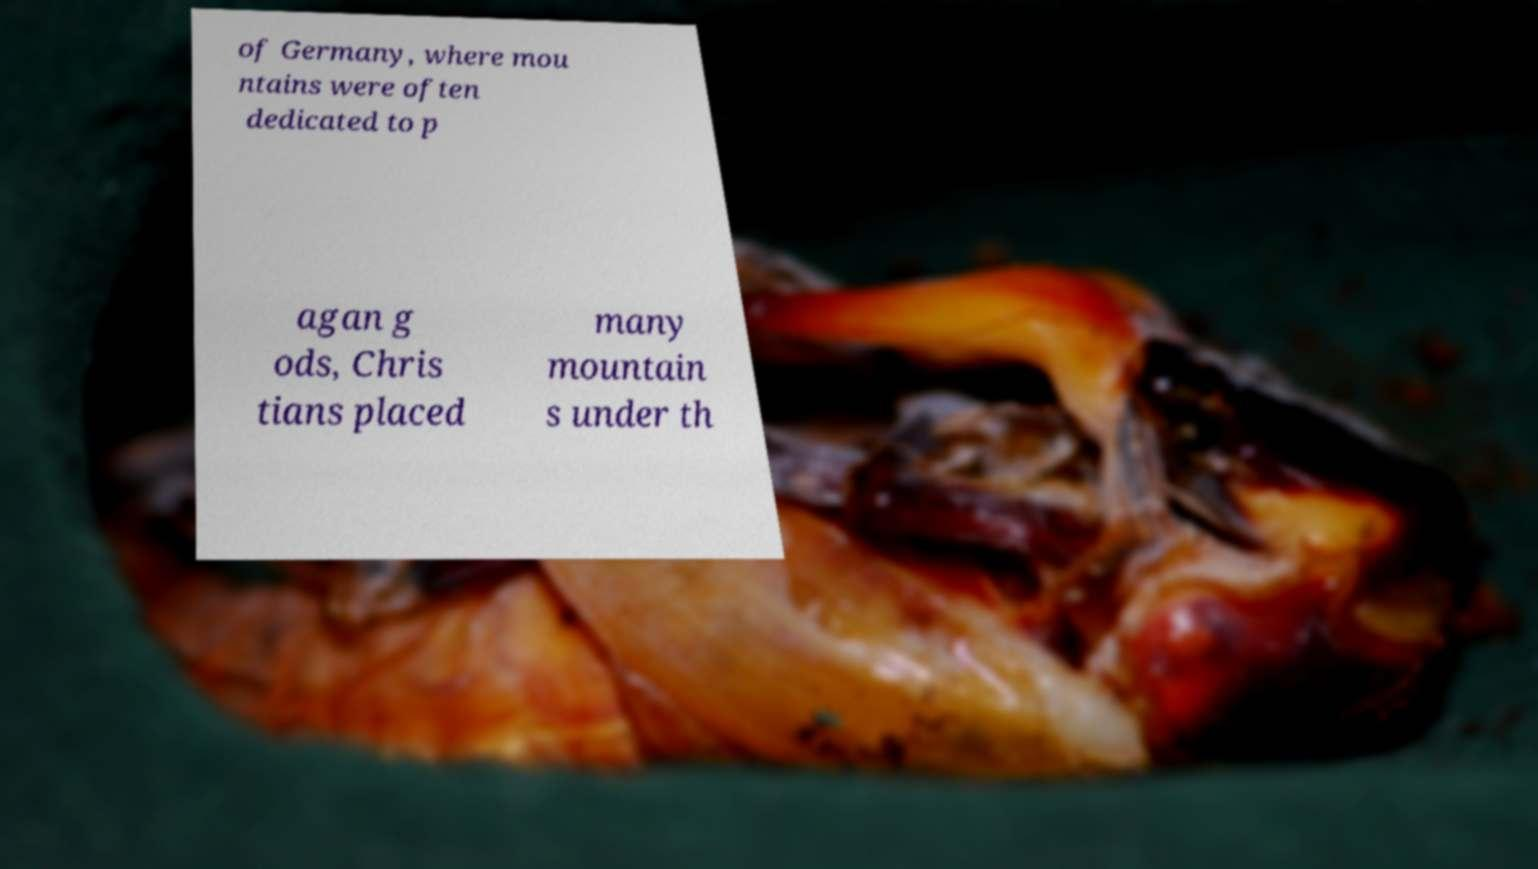Could you extract and type out the text from this image? of Germany, where mou ntains were often dedicated to p agan g ods, Chris tians placed many mountain s under th 